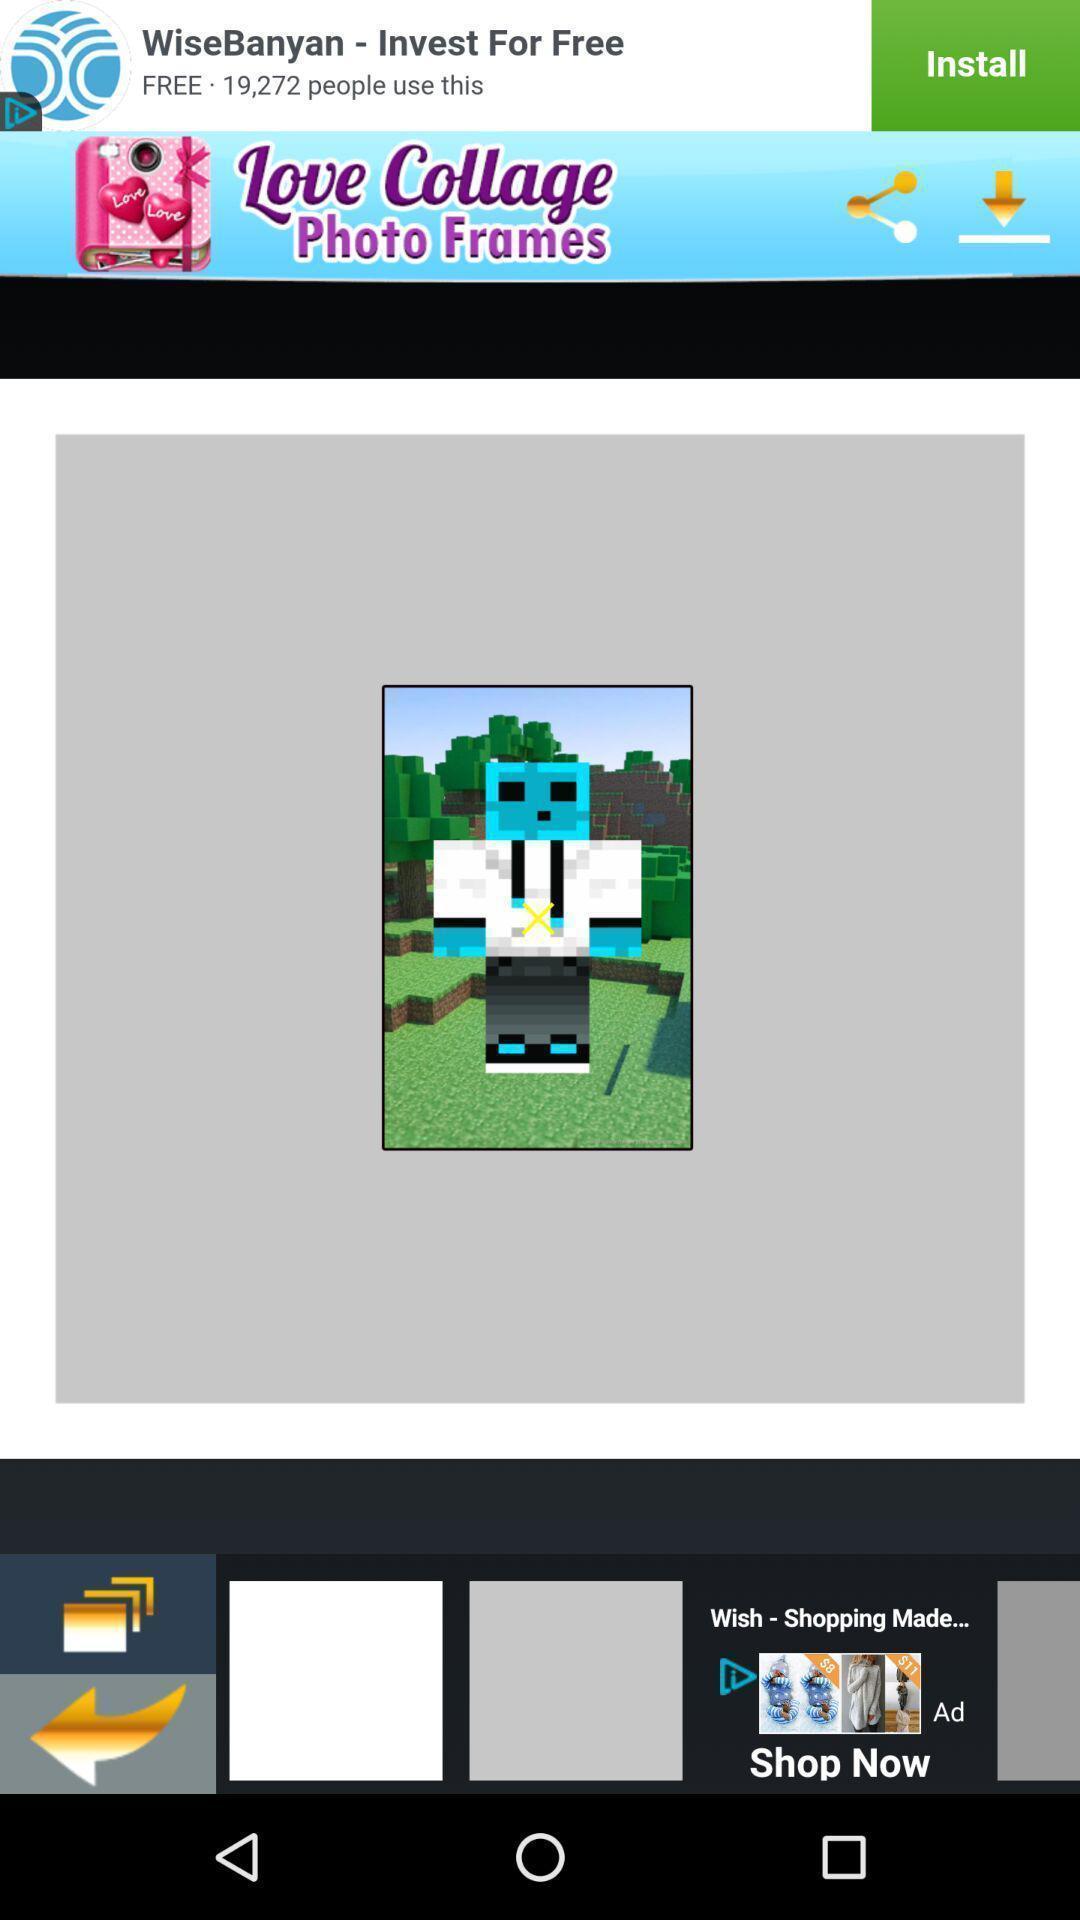Give me a summary of this screen capture. Screen shows image editing options in a edit app. 